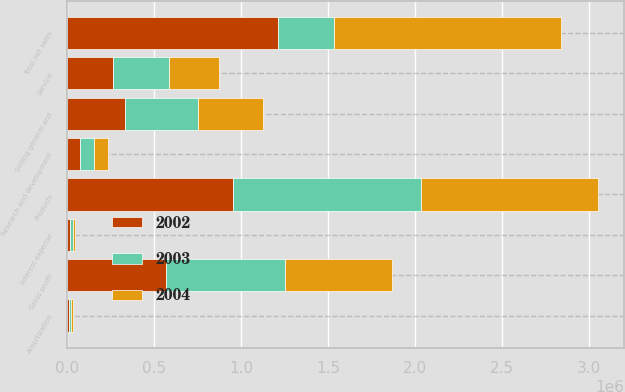<chart> <loc_0><loc_0><loc_500><loc_500><stacked_bar_chart><ecel><fcel>Products<fcel>Service<fcel>Total net sales<fcel>Gross profit<fcel>Research and development<fcel>Selling general and<fcel>Amortization<fcel>Interest expense<nl><fcel>2003<fcel>1.0821e+06<fcel>322357<fcel>322357<fcel>682407<fcel>83217<fcel>419780<fcel>12256<fcel>12888<nl><fcel>2004<fcel>1.01472e+06<fcel>289709<fcel>1.30443e+06<fcel>618176<fcel>78003<fcel>372822<fcel>11724<fcel>14153<nl><fcel>2002<fcel>954081<fcel>259626<fcel>1.21371e+06<fcel>567737<fcel>70625<fcel>331959<fcel>9332<fcel>17209<nl></chart> 